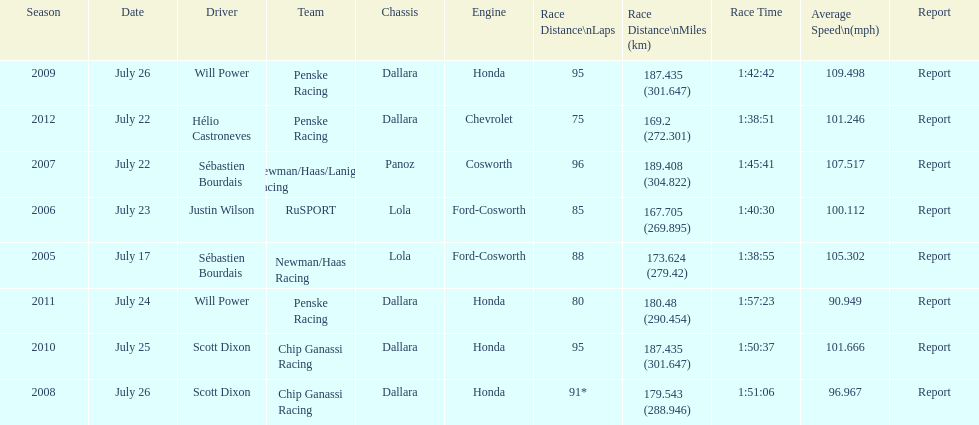How many different teams are represented in the table? 4. 